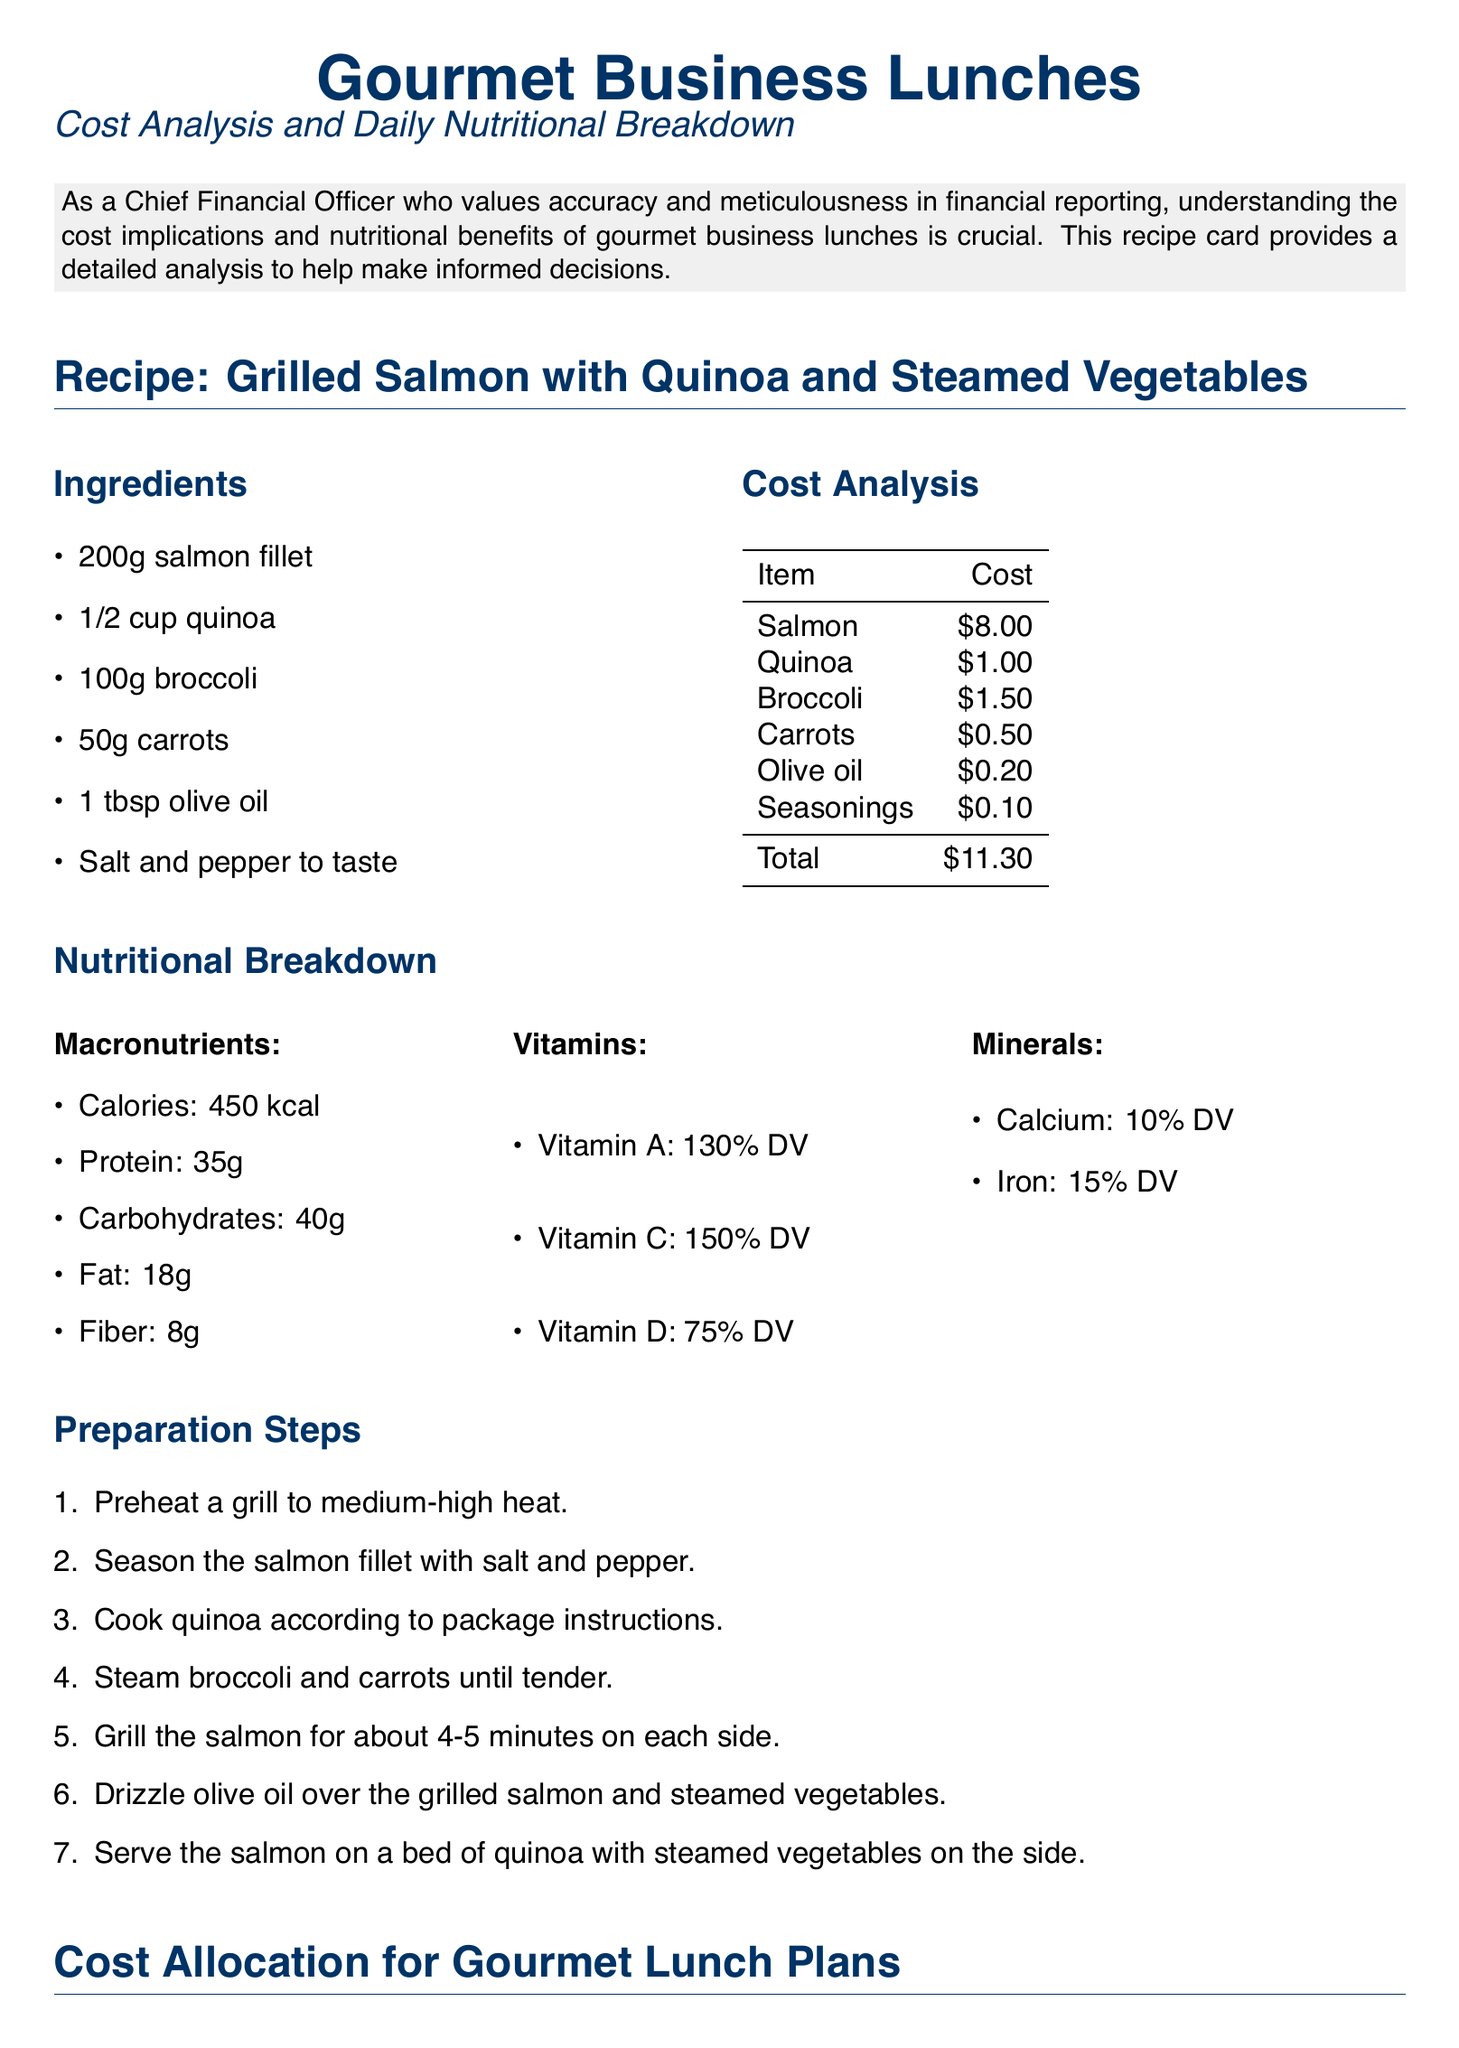What is the total cost of the ingredients? The total cost is calculated by adding up the individual costs of the ingredients listed in the cost analysis.
Answer: $11.30 What are the macronutrients of the meal? The macronutrients are detailed in the nutritional breakdown section, including calories, protein, carbohydrates, fat, and fiber.
Answer: Calories: 450 kcal, Protein: 35g, Carbohydrates: 40g, Fat: 18g, Fiber: 8g What is the protein content per meal? The protein content is specified in the nutritional breakdown, which indicates how much protein is provided in one serving of the meal.
Answer: 35g What is the estimated cost for a monthly gourmet lunch plan per person? The cost is derived from the cost allocation section, specifically looking at the monthly expenses for gourmet lunch plans.
Answer: $240.00 - $300.00 What is one vitamin included in the nutritional breakdown? The vitamins are listed in the nutritional breakdown section, highlighting their daily value percentages.
Answer: Vitamin A How long should the salmon be grilled? The preparation steps specify the cooking time for the salmon to ensure it is properly grilled.
Answer: 4-5 minutes What is the range of caloric intake recommended per meal? This range is specified in the nutritional goals section, indicating the ideal caloric range for business lunches.
Answer: 400-600 kcal What ingredient is used for dressing the grilled salmon? The ingredients list includes a specific item used to enhance the flavor of the dish.
Answer: Olive oil What is one economical benefit of gourmet business lunches? The economical benefits are highlighted in a specific section discussing positive outcomes for the company and employees.
Answer: Higher energy levels and productivity post-lunch 